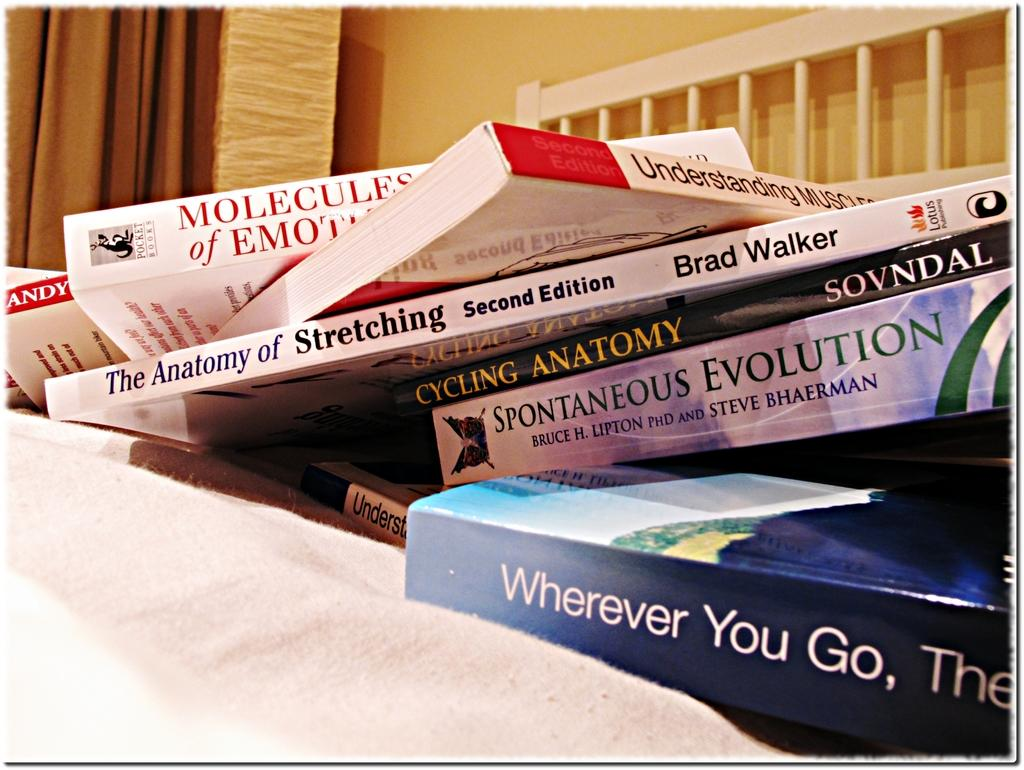<image>
Create a compact narrative representing the image presented. A book titled " The Anatomy of Stretching" and another book titled " Cycling Anatomy". 